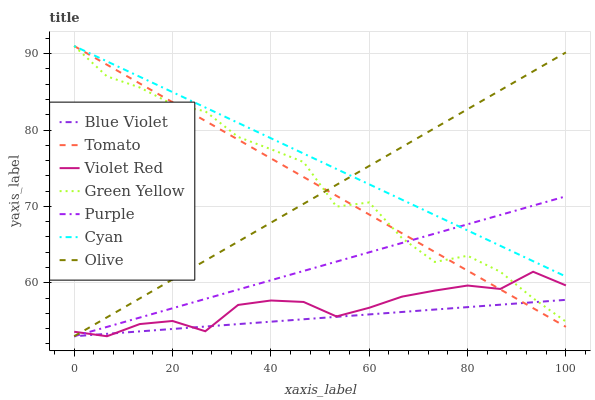Does Violet Red have the minimum area under the curve?
Answer yes or no. No. Does Violet Red have the maximum area under the curve?
Answer yes or no. No. Is Violet Red the smoothest?
Answer yes or no. No. Is Violet Red the roughest?
Answer yes or no. No. Does Cyan have the lowest value?
Answer yes or no. No. Does Violet Red have the highest value?
Answer yes or no. No. Is Violet Red less than Cyan?
Answer yes or no. Yes. Is Cyan greater than Blue Violet?
Answer yes or no. Yes. Does Violet Red intersect Cyan?
Answer yes or no. No. 